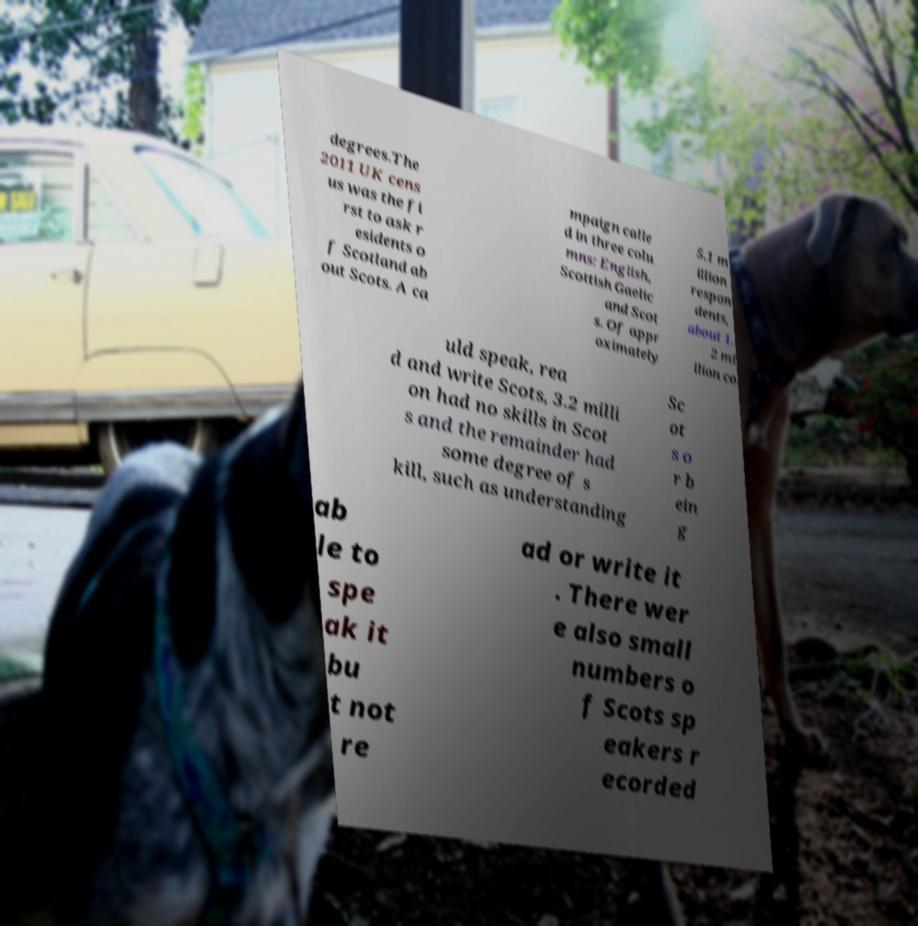Can you read and provide the text displayed in the image?This photo seems to have some interesting text. Can you extract and type it out for me? degrees.The 2011 UK cens us was the fi rst to ask r esidents o f Scotland ab out Scots. A ca mpaign calle d in three colu mns: English, Scottish Gaelic and Scot s. Of appr oximately 5.1 m illion respon dents, about 1. 2 mi llion co uld speak, rea d and write Scots, 3.2 milli on had no skills in Scot s and the remainder had some degree of s kill, such as understanding Sc ot s o r b ein g ab le to spe ak it bu t not re ad or write it . There wer e also small numbers o f Scots sp eakers r ecorded 